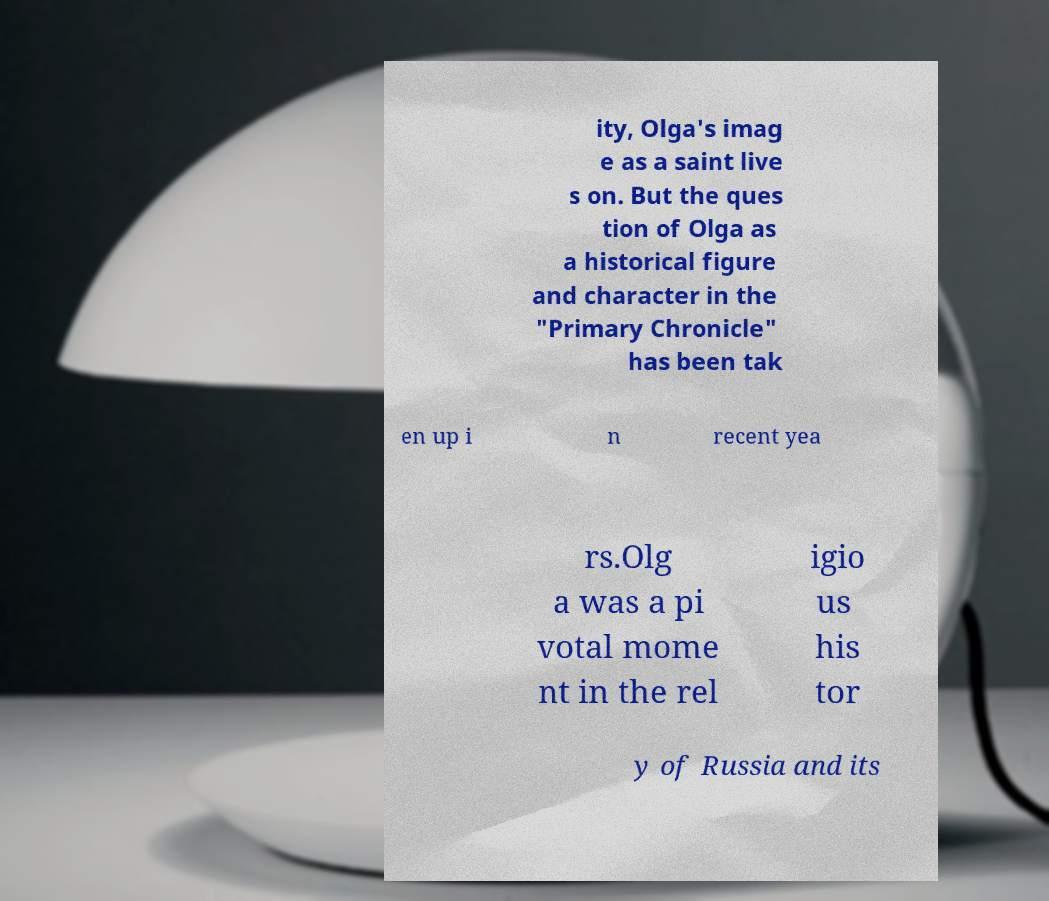Could you extract and type out the text from this image? ity, Olga's imag e as a saint live s on. But the ques tion of Olga as a historical figure and character in the "Primary Chronicle" has been tak en up i n recent yea rs.Olg a was a pi votal mome nt in the rel igio us his tor y of Russia and its 